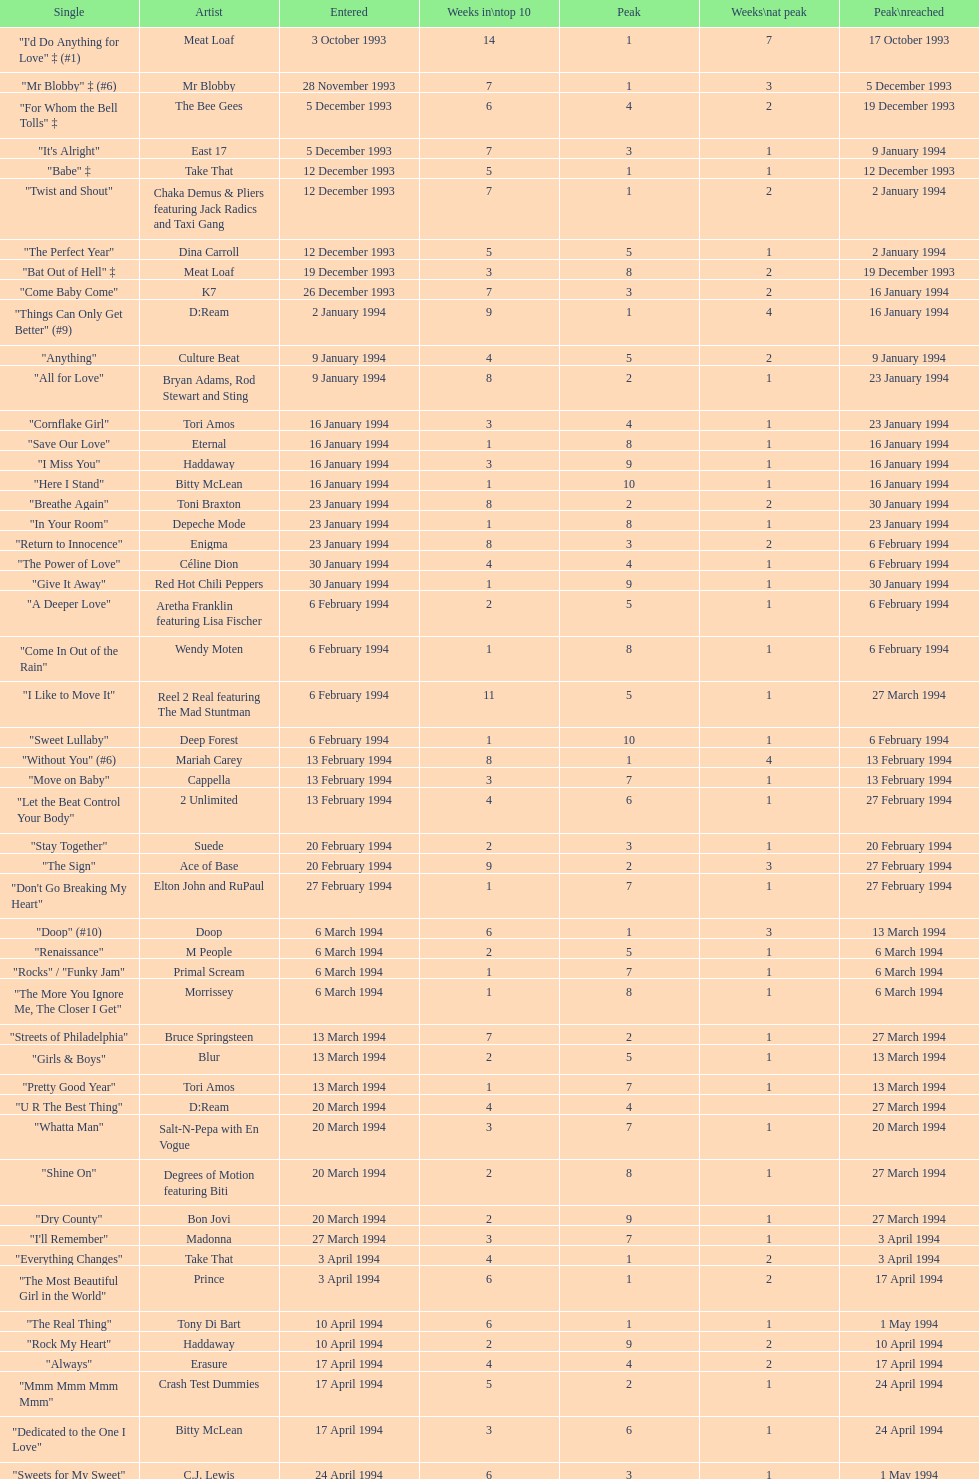Which artist only has its single entered on 2 january 1994? D:Ream. 